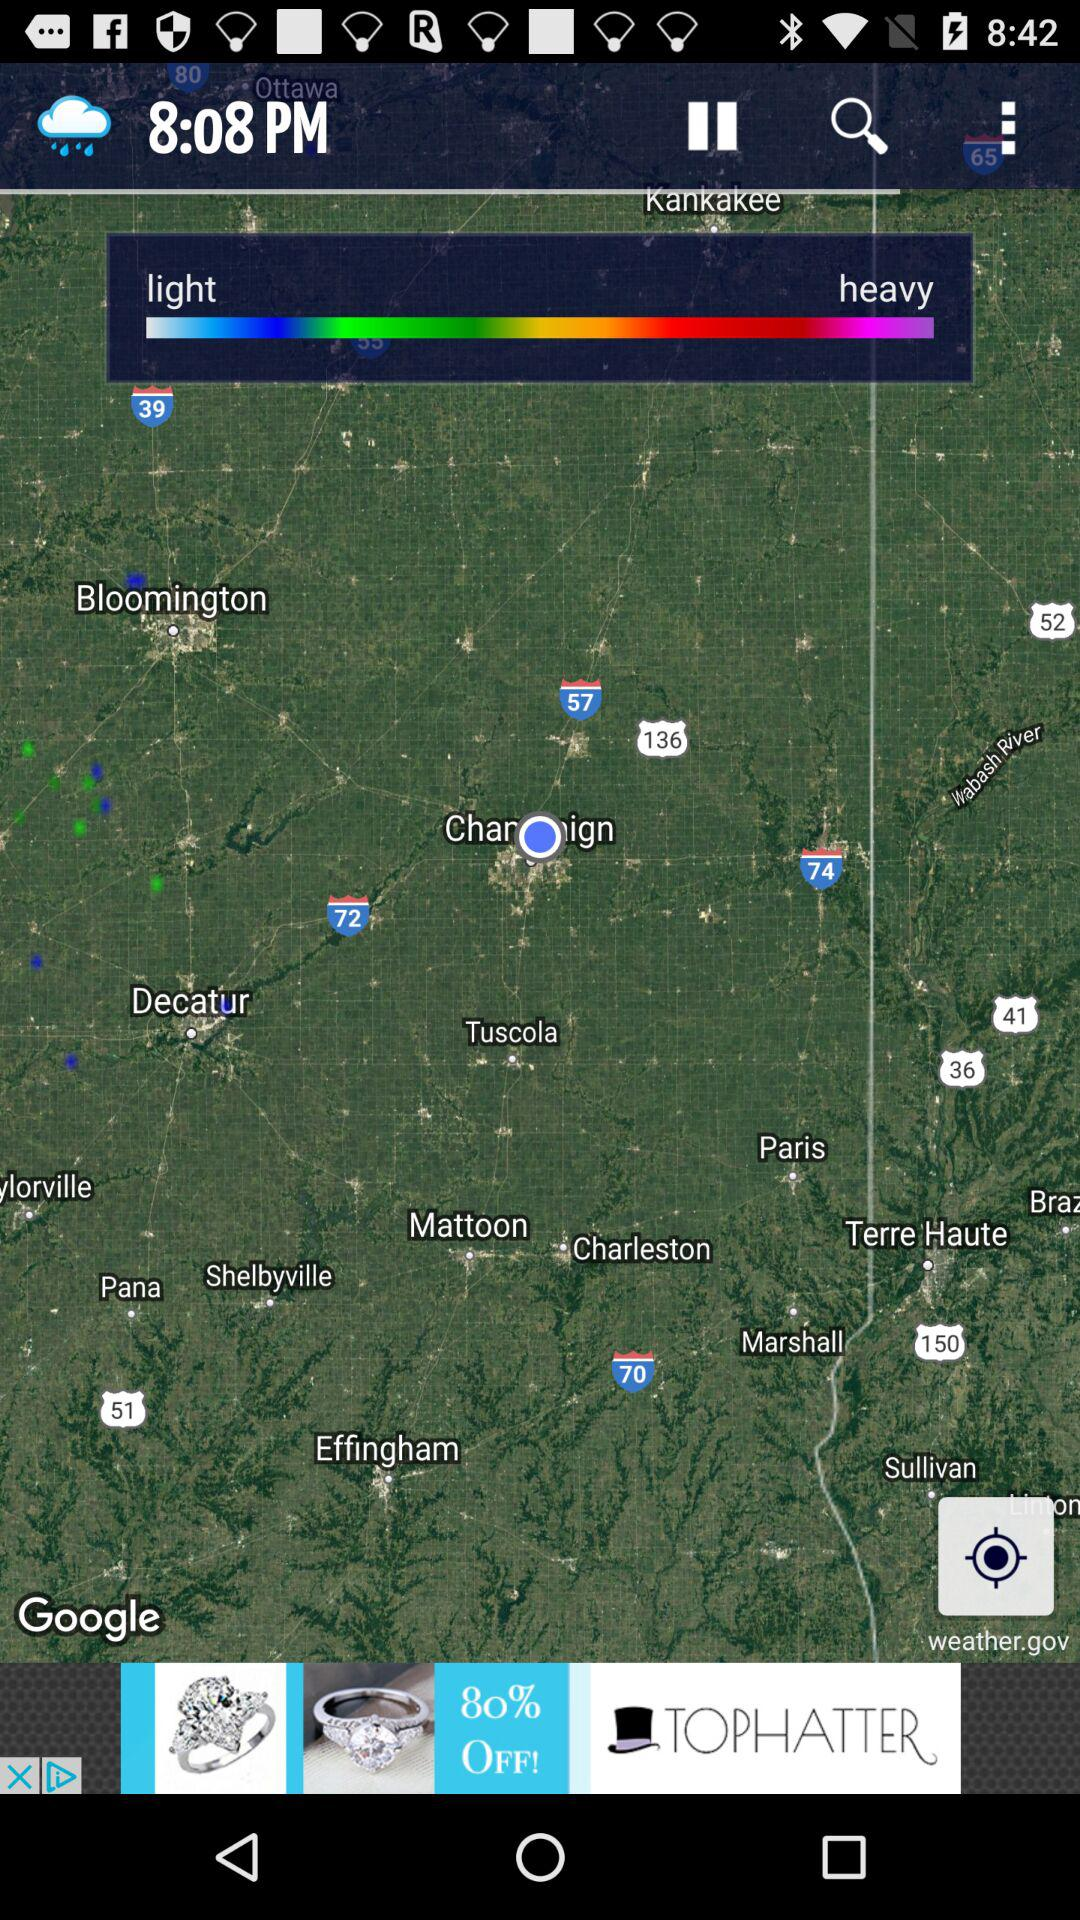How is the weather? The weather is rainy. 